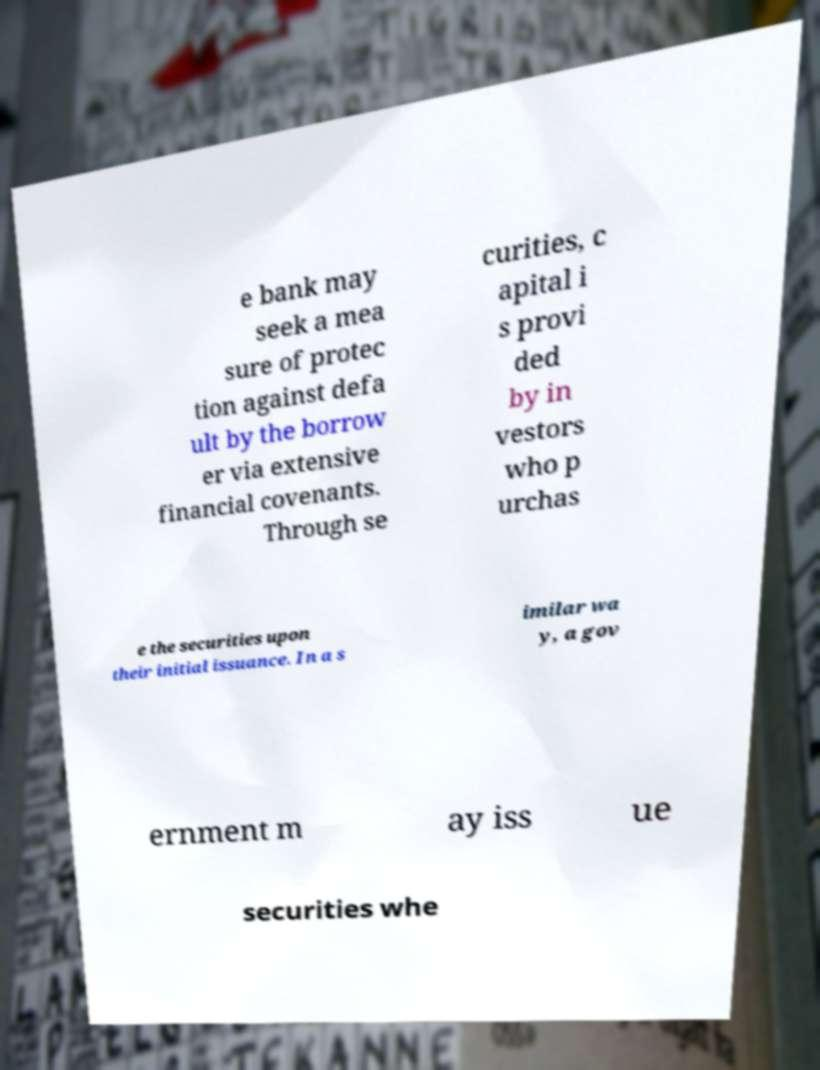Could you assist in decoding the text presented in this image and type it out clearly? e bank may seek a mea sure of protec tion against defa ult by the borrow er via extensive financial covenants. Through se curities, c apital i s provi ded by in vestors who p urchas e the securities upon their initial issuance. In a s imilar wa y, a gov ernment m ay iss ue securities whe 